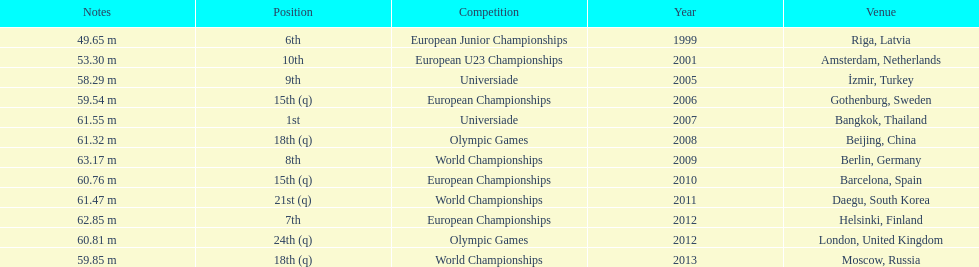Could you parse the entire table? {'header': ['Notes', 'Position', 'Competition', 'Year', 'Venue'], 'rows': [['49.65 m', '6th', 'European Junior Championships', '1999', 'Riga, Latvia'], ['53.30 m', '10th', 'European U23 Championships', '2001', 'Amsterdam, Netherlands'], ['58.29 m', '9th', 'Universiade', '2005', 'İzmir, Turkey'], ['59.54 m', '15th (q)', 'European Championships', '2006', 'Gothenburg, Sweden'], ['61.55 m', '1st', 'Universiade', '2007', 'Bangkok, Thailand'], ['61.32 m', '18th (q)', 'Olympic Games', '2008', 'Beijing, China'], ['63.17 m', '8th', 'World Championships', '2009', 'Berlin, Germany'], ['60.76 m', '15th (q)', 'European Championships', '2010', 'Barcelona, Spain'], ['61.47 m', '21st (q)', 'World Championships', '2011', 'Daegu, South Korea'], ['62.85 m', '7th', 'European Championships', '2012', 'Helsinki, Finland'], ['60.81 m', '24th (q)', 'Olympic Games', '2012', 'London, United Kingdom'], ['59.85 m', '18th (q)', 'World Championships', '2013', 'Moscow, Russia']]} Name two events in which mayer competed before he won the bangkok universiade. European Championships, Universiade. 